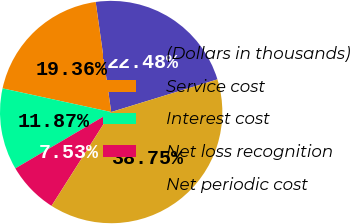<chart> <loc_0><loc_0><loc_500><loc_500><pie_chart><fcel>(Dollars in thousands)<fcel>Service cost<fcel>Interest cost<fcel>Net loss recognition<fcel>Net periodic cost<nl><fcel>22.48%<fcel>19.36%<fcel>11.87%<fcel>7.53%<fcel>38.75%<nl></chart> 